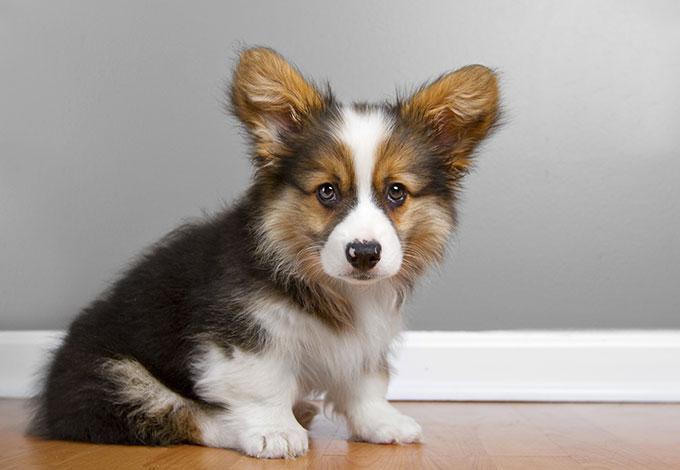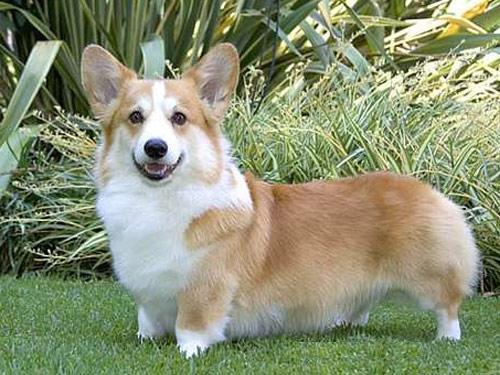The first image is the image on the left, the second image is the image on the right. Given the left and right images, does the statement "An image shows one orange-and-white dog, which wears a collar with a blue doggie bone-shaped charm." hold true? Answer yes or no. No. The first image is the image on the left, the second image is the image on the right. Examine the images to the left and right. Is the description "There are two dogs and neither of them have any black fur." accurate? Answer yes or no. No. The first image is the image on the left, the second image is the image on the right. Given the left and right images, does the statement "The dog in the right hand image stands on grass while the dog in the left hand image does not." hold true? Answer yes or no. Yes. The first image is the image on the left, the second image is the image on the right. Assess this claim about the two images: "An image shows one short-legged dog standing in profile on green grass, with its face turned to the camera.". Correct or not? Answer yes or no. Yes. 